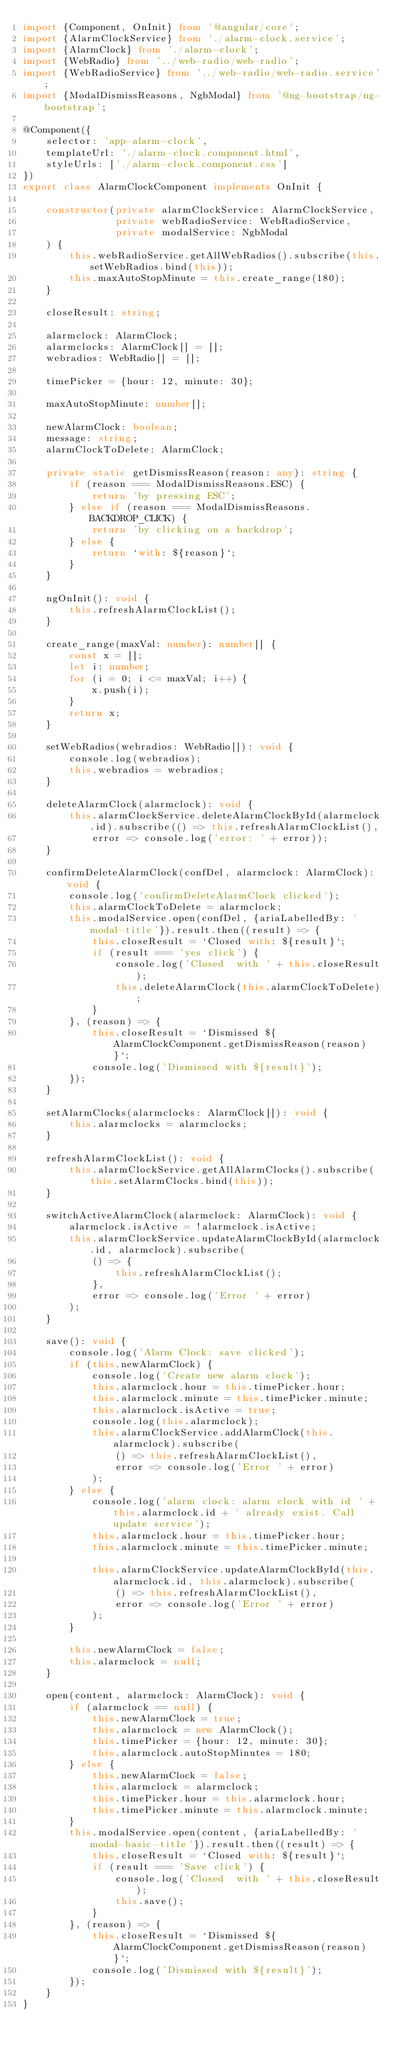<code> <loc_0><loc_0><loc_500><loc_500><_TypeScript_>import {Component, OnInit} from '@angular/core';
import {AlarmClockService} from './alarm-clock.service';
import {AlarmClock} from './alarm-clock';
import {WebRadio} from '../web-radio/web-radio';
import {WebRadioService} from '../web-radio/web-radio.service';
import {ModalDismissReasons, NgbModal} from '@ng-bootstrap/ng-bootstrap';

@Component({
    selector: 'app-alarm-clock',
    templateUrl: './alarm-clock.component.html',
    styleUrls: ['./alarm-clock.component.css']
})
export class AlarmClockComponent implements OnInit {

    constructor(private alarmClockService: AlarmClockService,
                private webRadioService: WebRadioService,
                private modalService: NgbModal
    ) {
        this.webRadioService.getAllWebRadios().subscribe(this.setWebRadios.bind(this));
        this.maxAutoStopMinute = this.create_range(180);
    }

    closeResult: string;

    alarmclock: AlarmClock;
    alarmclocks: AlarmClock[] = [];
    webradios: WebRadio[] = [];

    timePicker = {hour: 12, minute: 30};

    maxAutoStopMinute: number[];

    newAlarmClock: boolean;
    message: string;
    alarmClockToDelete: AlarmClock;

    private static getDismissReason(reason: any): string {
        if (reason === ModalDismissReasons.ESC) {
            return 'by pressing ESC';
        } else if (reason === ModalDismissReasons.BACKDROP_CLICK) {
            return 'by clicking on a backdrop';
        } else {
            return `with: ${reason}`;
        }
    }

    ngOnInit(): void {
        this.refreshAlarmClockList();
    }

    create_range(maxVal: number): number[] {
        const x = [];
        let i: number;
        for (i = 0; i <= maxVal; i++) {
            x.push(i);
        }
        return x;
    }

    setWebRadios(webradios: WebRadio[]): void {
        console.log(webradios);
        this.webradios = webradios;
    }

    deleteAlarmClock(alarmclock): void {
        this.alarmClockService.deleteAlarmClockById(alarmclock.id).subscribe(() => this.refreshAlarmClockList(),
            error => console.log('error: ' + error));
    }

    confirmDeleteAlarmClock(confDel, alarmclock: AlarmClock): void {
        console.log('confirmDeleteAlarmClock clicked');
        this.alarmClockToDelete = alarmclock;
        this.modalService.open(confDel, {ariaLabelledBy: 'modal-title'}).result.then((result) => {
            this.closeResult = `Closed with: ${result}`;
            if (result === 'yes click') {
                console.log('Closed  with ' + this.closeResult);
                this.deleteAlarmClock(this.alarmClockToDelete);
            }
        }, (reason) => {
            this.closeResult = `Dismissed ${AlarmClockComponent.getDismissReason(reason)}`;
            console.log('Dismissed with ${result}');
        });
    }

    setAlarmClocks(alarmclocks: AlarmClock[]): void {
        this.alarmclocks = alarmclocks;
    }

    refreshAlarmClockList(): void {
        this.alarmClockService.getAllAlarmClocks().subscribe(this.setAlarmClocks.bind(this));
    }

    switchActiveAlarmClock(alarmclock: AlarmClock): void {
        alarmclock.isActive = !alarmclock.isActive;
        this.alarmClockService.updateAlarmClockById(alarmclock.id, alarmclock).subscribe(
            () => {
                this.refreshAlarmClockList();
            },
            error => console.log('Error ' + error)
        );
    }

    save(): void {
        console.log('Alarm Clock: save clicked');
        if (this.newAlarmClock) {
            console.log('Create new alarm clock');
            this.alarmclock.hour = this.timePicker.hour;
            this.alarmclock.minute = this.timePicker.minute;
            this.alarmclock.isActive = true;
            console.log(this.alarmclock);
            this.alarmClockService.addAlarmClock(this.alarmclock).subscribe(
                () => this.refreshAlarmClockList(),
                error => console.log('Error ' + error)
            );
        } else {
            console.log('alarm clock: alarm clock with id ' + this.alarmclock.id + ' already exist. Call update service');
            this.alarmclock.hour = this.timePicker.hour;
            this.alarmclock.minute = this.timePicker.minute;

            this.alarmClockService.updateAlarmClockById(this.alarmclock.id, this.alarmclock).subscribe(
                () => this.refreshAlarmClockList(),
                error => console.log('Error ' + error)
            );
        }

        this.newAlarmClock = false;
        this.alarmclock = null;
    }

    open(content, alarmclock: AlarmClock): void {
        if (alarmclock == null) {
            this.newAlarmClock = true;
            this.alarmclock = new AlarmClock();
            this.timePicker = {hour: 12, minute: 30};
            this.alarmclock.autoStopMinutes = 180;
        } else {
            this.newAlarmClock = false;
            this.alarmclock = alarmclock;
            this.timePicker.hour = this.alarmclock.hour;
            this.timePicker.minute = this.alarmclock.minute;
        }
        this.modalService.open(content, {ariaLabelledBy: 'modal-basic-title'}).result.then((result) => {
            this.closeResult = `Closed with: ${result}`;
            if (result === 'Save click') {
                console.log('Closed  with ' + this.closeResult);
                this.save();
            }
        }, (reason) => {
            this.closeResult = `Dismissed ${AlarmClockComponent.getDismissReason(reason)}`;
            console.log('Dismissed with ${result}');
        });
    }
}
</code> 